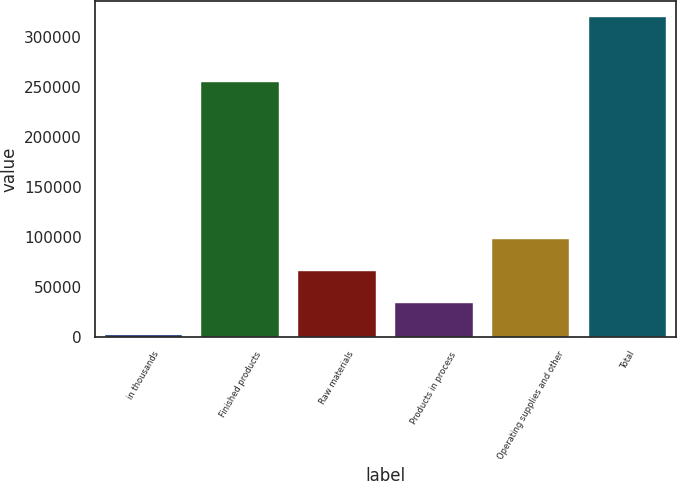Convert chart to OTSL. <chart><loc_0><loc_0><loc_500><loc_500><bar_chart><fcel>in thousands<fcel>Finished products<fcel>Raw materials<fcel>Products in process<fcel>Operating supplies and other<fcel>Total<nl><fcel>2010<fcel>254840<fcel>65577<fcel>33793.5<fcel>97360.5<fcel>319845<nl></chart> 